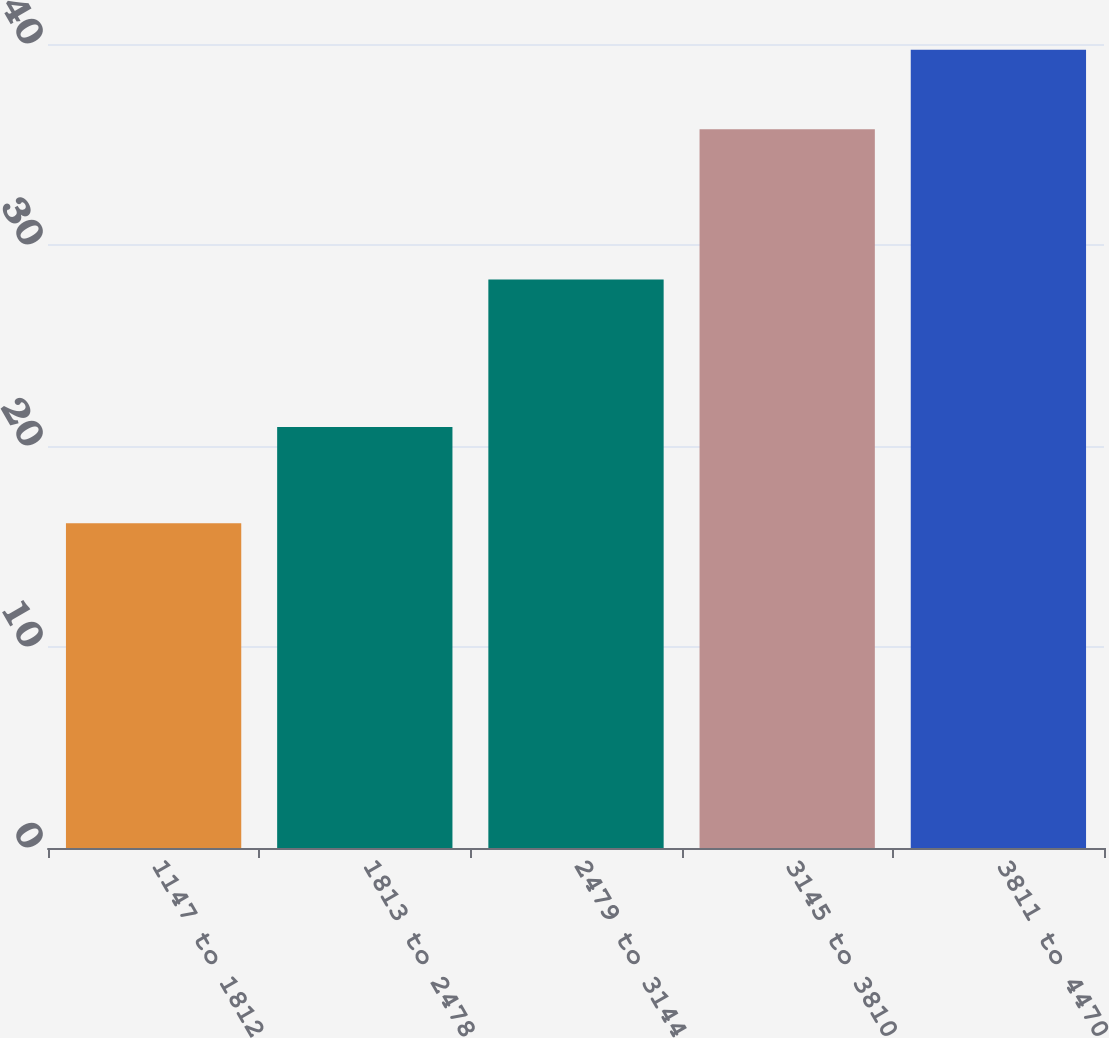Convert chart to OTSL. <chart><loc_0><loc_0><loc_500><loc_500><bar_chart><fcel>1147 to 1812<fcel>1813 to 2478<fcel>2479 to 3144<fcel>3145 to 3810<fcel>3811 to 4470<nl><fcel>16.16<fcel>20.95<fcel>28.28<fcel>35.76<fcel>39.72<nl></chart> 